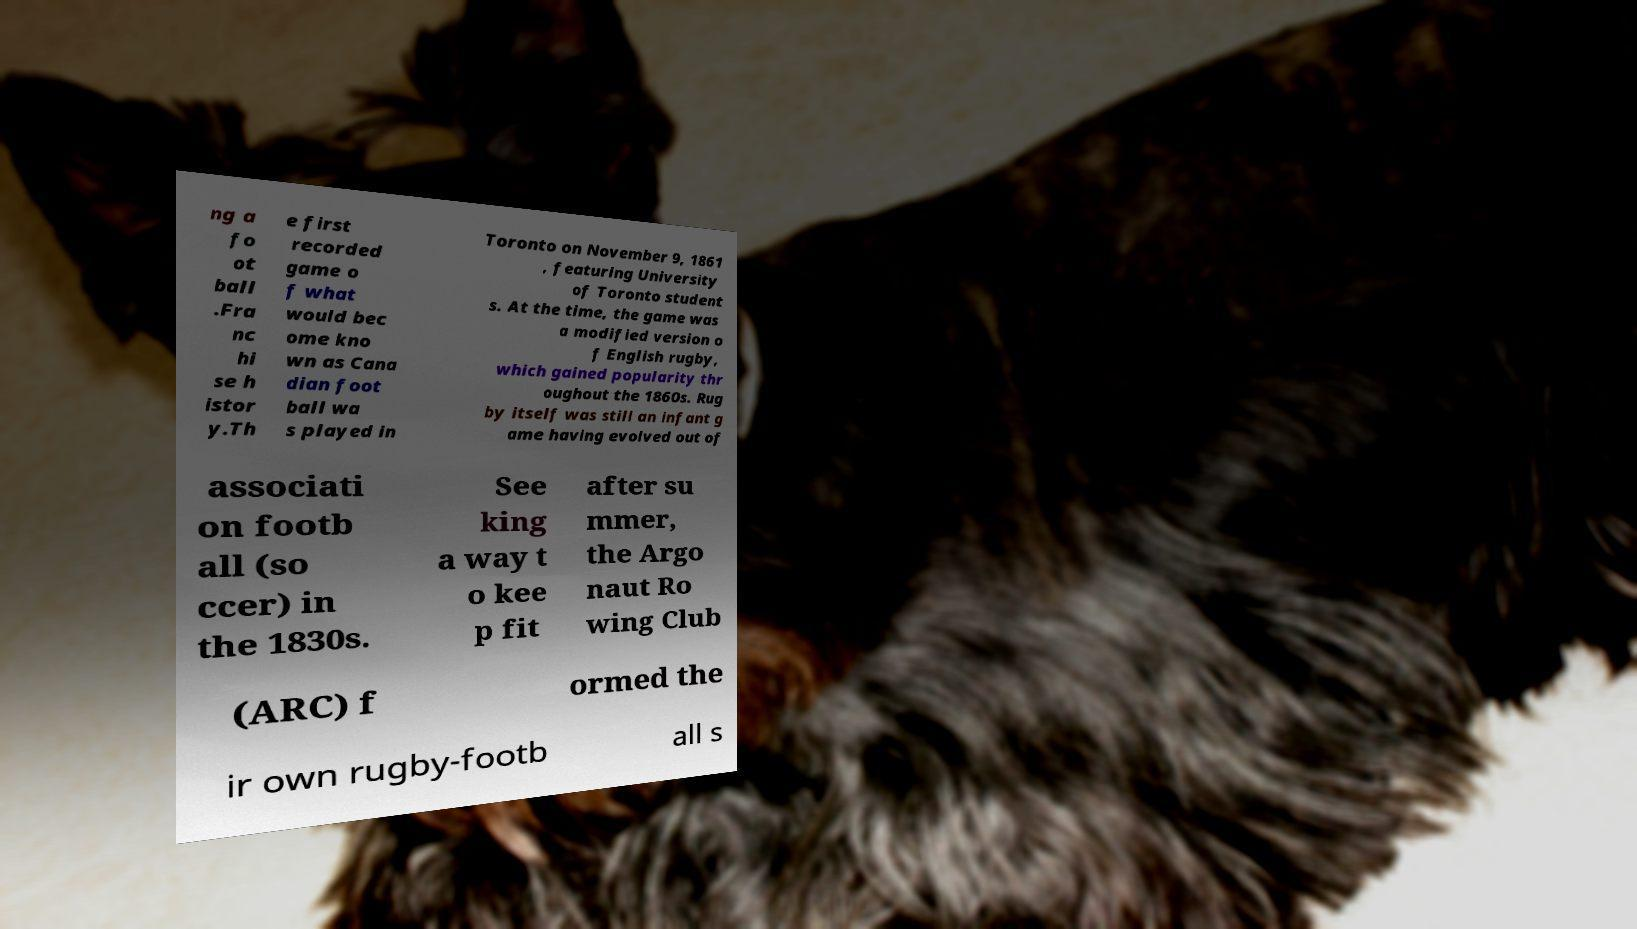There's text embedded in this image that I need extracted. Can you transcribe it verbatim? ng a fo ot ball .Fra nc hi se h istor y.Th e first recorded game o f what would bec ome kno wn as Cana dian foot ball wa s played in Toronto on November 9, 1861 , featuring University of Toronto student s. At the time, the game was a modified version o f English rugby, which gained popularity thr oughout the 1860s. Rug by itself was still an infant g ame having evolved out of associati on footb all (so ccer) in the 1830s. See king a way t o kee p fit after su mmer, the Argo naut Ro wing Club (ARC) f ormed the ir own rugby-footb all s 